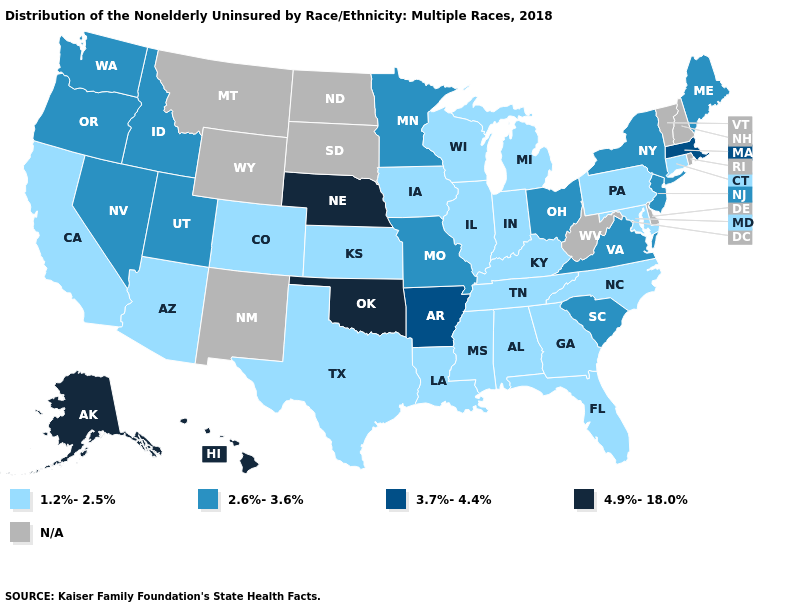Name the states that have a value in the range 3.7%-4.4%?
Keep it brief. Arkansas, Massachusetts. What is the value of Delaware?
Be succinct. N/A. Which states have the highest value in the USA?
Write a very short answer. Alaska, Hawaii, Nebraska, Oklahoma. What is the lowest value in states that border Tennessee?
Quick response, please. 1.2%-2.5%. Which states have the lowest value in the USA?
Give a very brief answer. Alabama, Arizona, California, Colorado, Connecticut, Florida, Georgia, Illinois, Indiana, Iowa, Kansas, Kentucky, Louisiana, Maryland, Michigan, Mississippi, North Carolina, Pennsylvania, Tennessee, Texas, Wisconsin. Name the states that have a value in the range 1.2%-2.5%?
Concise answer only. Alabama, Arizona, California, Colorado, Connecticut, Florida, Georgia, Illinois, Indiana, Iowa, Kansas, Kentucky, Louisiana, Maryland, Michigan, Mississippi, North Carolina, Pennsylvania, Tennessee, Texas, Wisconsin. Among the states that border Wisconsin , does Illinois have the lowest value?
Be succinct. Yes. What is the lowest value in states that border California?
Quick response, please. 1.2%-2.5%. What is the value of Kentucky?
Give a very brief answer. 1.2%-2.5%. What is the highest value in states that border New York?
Write a very short answer. 3.7%-4.4%. Does the map have missing data?
Keep it brief. Yes. Name the states that have a value in the range 4.9%-18.0%?
Write a very short answer. Alaska, Hawaii, Nebraska, Oklahoma. What is the value of Montana?
Be succinct. N/A. Among the states that border North Carolina , which have the highest value?
Be succinct. South Carolina, Virginia. 